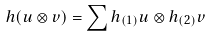Convert formula to latex. <formula><loc_0><loc_0><loc_500><loc_500>h ( u \otimes v ) = \sum h _ { ( 1 ) } u \otimes h _ { ( 2 ) } v</formula> 